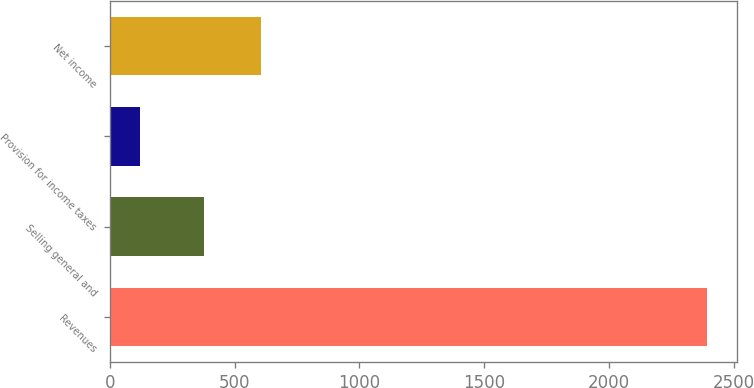Convert chart to OTSL. <chart><loc_0><loc_0><loc_500><loc_500><bar_chart><fcel>Revenues<fcel>Selling general and<fcel>Provision for income taxes<fcel>Net income<nl><fcel>2395.1<fcel>378.7<fcel>121<fcel>606.11<nl></chart> 